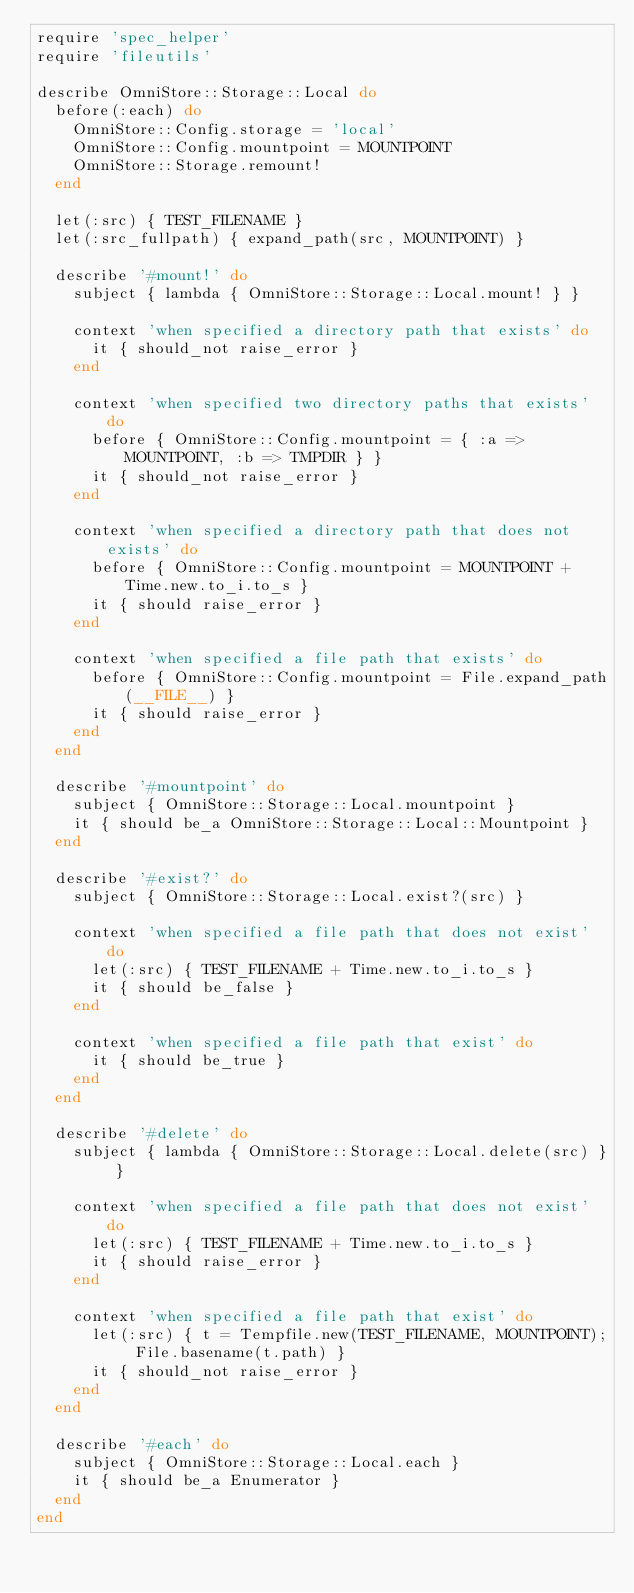Convert code to text. <code><loc_0><loc_0><loc_500><loc_500><_Ruby_>require 'spec_helper'
require 'fileutils'

describe OmniStore::Storage::Local do
  before(:each) do
    OmniStore::Config.storage = 'local'
    OmniStore::Config.mountpoint = MOUNTPOINT
    OmniStore::Storage.remount!
  end

  let(:src) { TEST_FILENAME }
  let(:src_fullpath) { expand_path(src, MOUNTPOINT) }

  describe '#mount!' do
    subject { lambda { OmniStore::Storage::Local.mount! } }

    context 'when specified a directory path that exists' do
      it { should_not raise_error }
    end

    context 'when specified two directory paths that exists' do
      before { OmniStore::Config.mountpoint = { :a => MOUNTPOINT, :b => TMPDIR } }
      it { should_not raise_error }
    end

    context 'when specified a directory path that does not exists' do
      before { OmniStore::Config.mountpoint = MOUNTPOINT + Time.new.to_i.to_s }
      it { should raise_error }
    end

    context 'when specified a file path that exists' do
      before { OmniStore::Config.mountpoint = File.expand_path(__FILE__) }
      it { should raise_error }
    end
  end

  describe '#mountpoint' do
    subject { OmniStore::Storage::Local.mountpoint }
    it { should be_a OmniStore::Storage::Local::Mountpoint }
  end

  describe '#exist?' do
    subject { OmniStore::Storage::Local.exist?(src) }

    context 'when specified a file path that does not exist' do
      let(:src) { TEST_FILENAME + Time.new.to_i.to_s }
      it { should be_false } 
    end

    context 'when specified a file path that exist' do
      it { should be_true } 
    end
  end

  describe '#delete' do
    subject { lambda { OmniStore::Storage::Local.delete(src) } }

    context 'when specified a file path that does not exist' do
      let(:src) { TEST_FILENAME + Time.new.to_i.to_s }
      it { should raise_error } 
    end

    context 'when specified a file path that exist' do
      let(:src) { t = Tempfile.new(TEST_FILENAME, MOUNTPOINT); File.basename(t.path) }
      it { should_not raise_error } 
    end
  end

  describe '#each' do
    subject { OmniStore::Storage::Local.each }
    it { should be_a Enumerator }
  end
end
</code> 